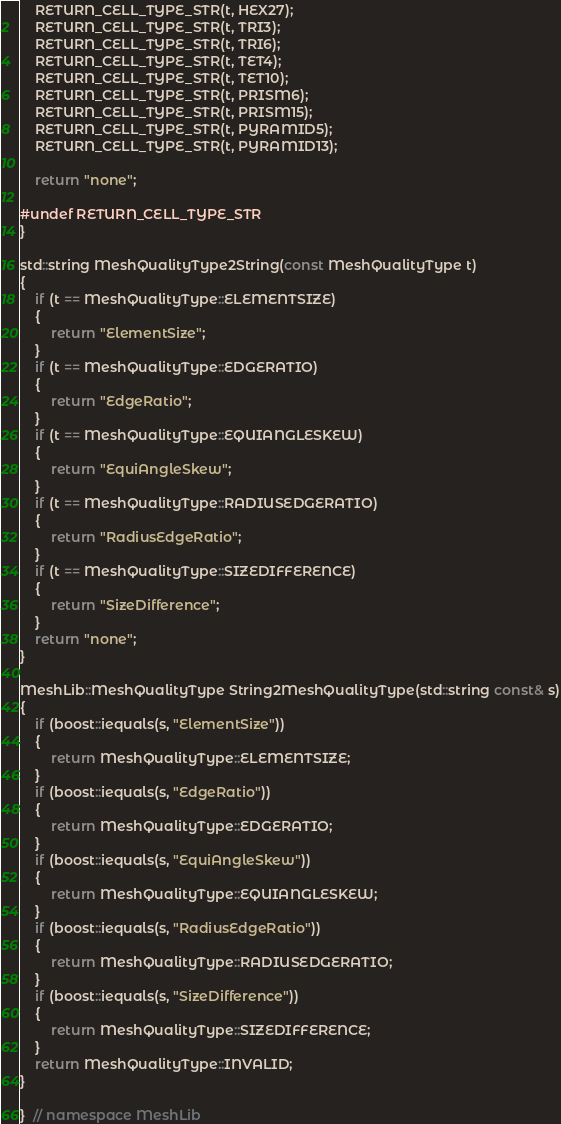<code> <loc_0><loc_0><loc_500><loc_500><_C++_>    RETURN_CELL_TYPE_STR(t, HEX27);
    RETURN_CELL_TYPE_STR(t, TRI3);
    RETURN_CELL_TYPE_STR(t, TRI6);
    RETURN_CELL_TYPE_STR(t, TET4);
    RETURN_CELL_TYPE_STR(t, TET10);
    RETURN_CELL_TYPE_STR(t, PRISM6);
    RETURN_CELL_TYPE_STR(t, PRISM15);
    RETURN_CELL_TYPE_STR(t, PYRAMID5);
    RETURN_CELL_TYPE_STR(t, PYRAMID13);

    return "none";

#undef RETURN_CELL_TYPE_STR
}

std::string MeshQualityType2String(const MeshQualityType t)
{
    if (t == MeshQualityType::ELEMENTSIZE)
    {
        return "ElementSize";
    }
    if (t == MeshQualityType::EDGERATIO)
    {
        return "EdgeRatio";
    }
    if (t == MeshQualityType::EQUIANGLESKEW)
    {
        return "EquiAngleSkew";
    }
    if (t == MeshQualityType::RADIUSEDGERATIO)
    {
        return "RadiusEdgeRatio";
    }
    if (t == MeshQualityType::SIZEDIFFERENCE)
    {
        return "SizeDifference";
    }
    return "none";
}

MeshLib::MeshQualityType String2MeshQualityType(std::string const& s)
{
    if (boost::iequals(s, "ElementSize"))
    {
        return MeshQualityType::ELEMENTSIZE;
    }
    if (boost::iequals(s, "EdgeRatio"))
    {
        return MeshQualityType::EDGERATIO;
    }
    if (boost::iequals(s, "EquiAngleSkew"))
    {
        return MeshQualityType::EQUIANGLESKEW;
    }
    if (boost::iequals(s, "RadiusEdgeRatio"))
    {
        return MeshQualityType::RADIUSEDGERATIO;
    }
    if (boost::iequals(s, "SizeDifference"))
    {
        return MeshQualityType::SIZEDIFFERENCE;
    }
    return MeshQualityType::INVALID;
}

}  // namespace MeshLib
</code> 